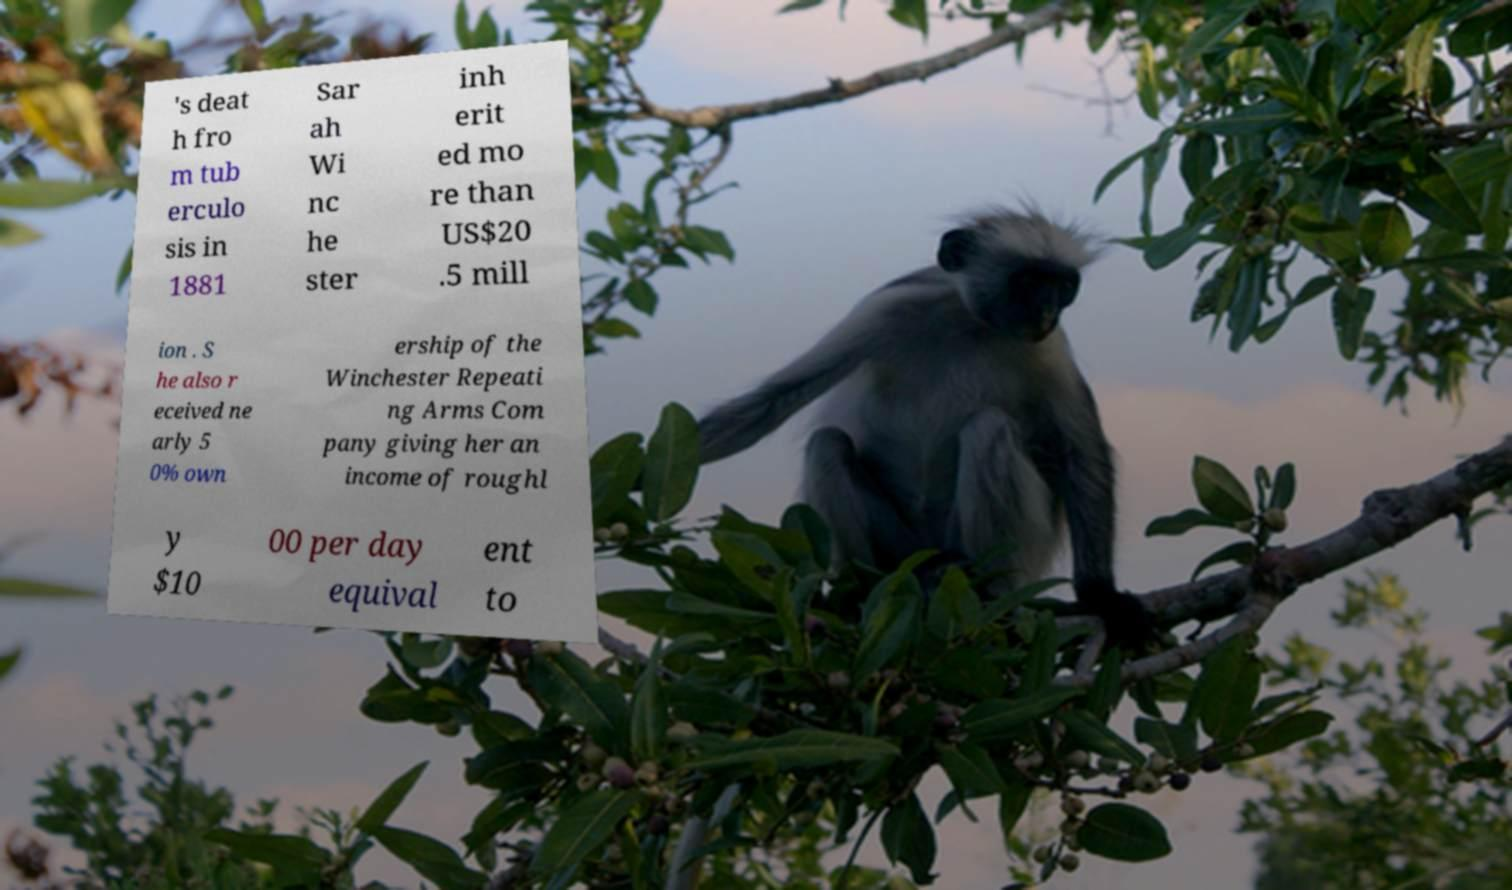Please identify and transcribe the text found in this image. 's deat h fro m tub erculo sis in 1881 Sar ah Wi nc he ster inh erit ed mo re than US$20 .5 mill ion . S he also r eceived ne arly 5 0% own ership of the Winchester Repeati ng Arms Com pany giving her an income of roughl y $10 00 per day equival ent to 